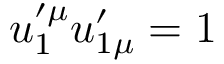<formula> <loc_0><loc_0><loc_500><loc_500>u _ { 1 } ^ { \prime \mu } u _ { 1 \mu } ^ { \prime } = 1</formula> 